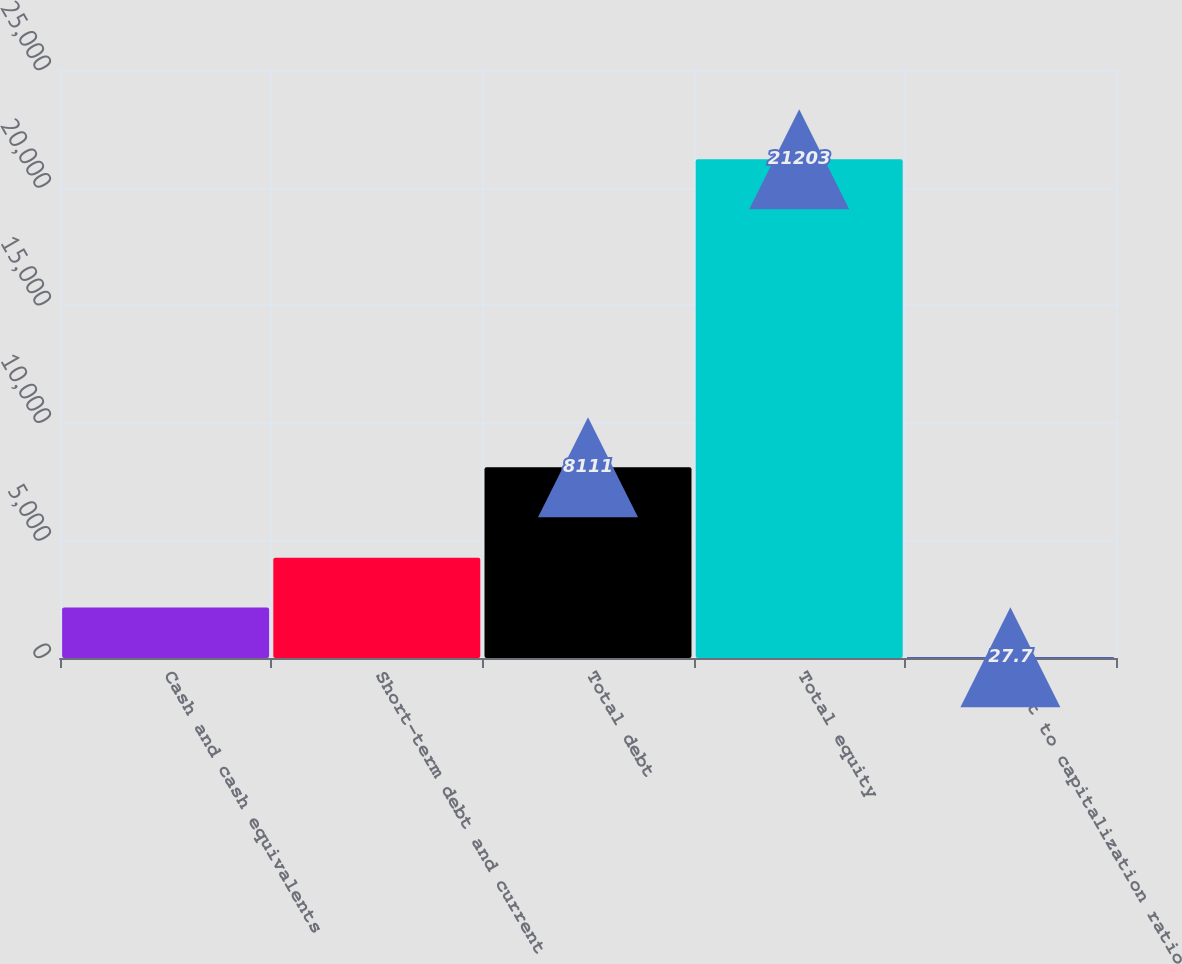<chart> <loc_0><loc_0><loc_500><loc_500><bar_chart><fcel>Cash and cash equivalents<fcel>Short-term debt and current<fcel>Total debt<fcel>Total equity<fcel>Debt to capitalization ratio<nl><fcel>2145.23<fcel>4262.76<fcel>8111<fcel>21203<fcel>27.7<nl></chart> 